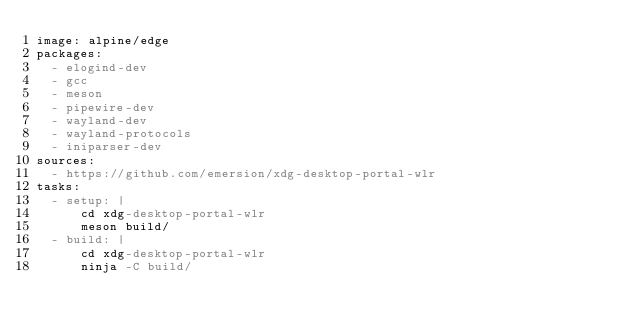<code> <loc_0><loc_0><loc_500><loc_500><_YAML_>image: alpine/edge
packages:
  - elogind-dev
  - gcc
  - meson
  - pipewire-dev
  - wayland-dev
  - wayland-protocols
  - iniparser-dev
sources:
  - https://github.com/emersion/xdg-desktop-portal-wlr
tasks:
  - setup: |
      cd xdg-desktop-portal-wlr
      meson build/
  - build: |
      cd xdg-desktop-portal-wlr
      ninja -C build/
</code> 